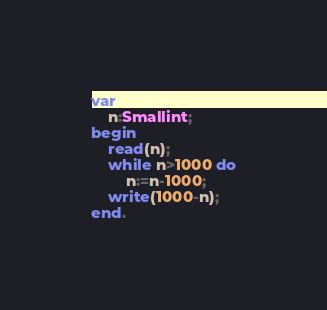Convert code to text. <code><loc_0><loc_0><loc_500><loc_500><_Pascal_>var
	n:Smallint;
begin
    read(n);
    while n>1000 do
        n:=n-1000;
    write(1000-n);
end.</code> 